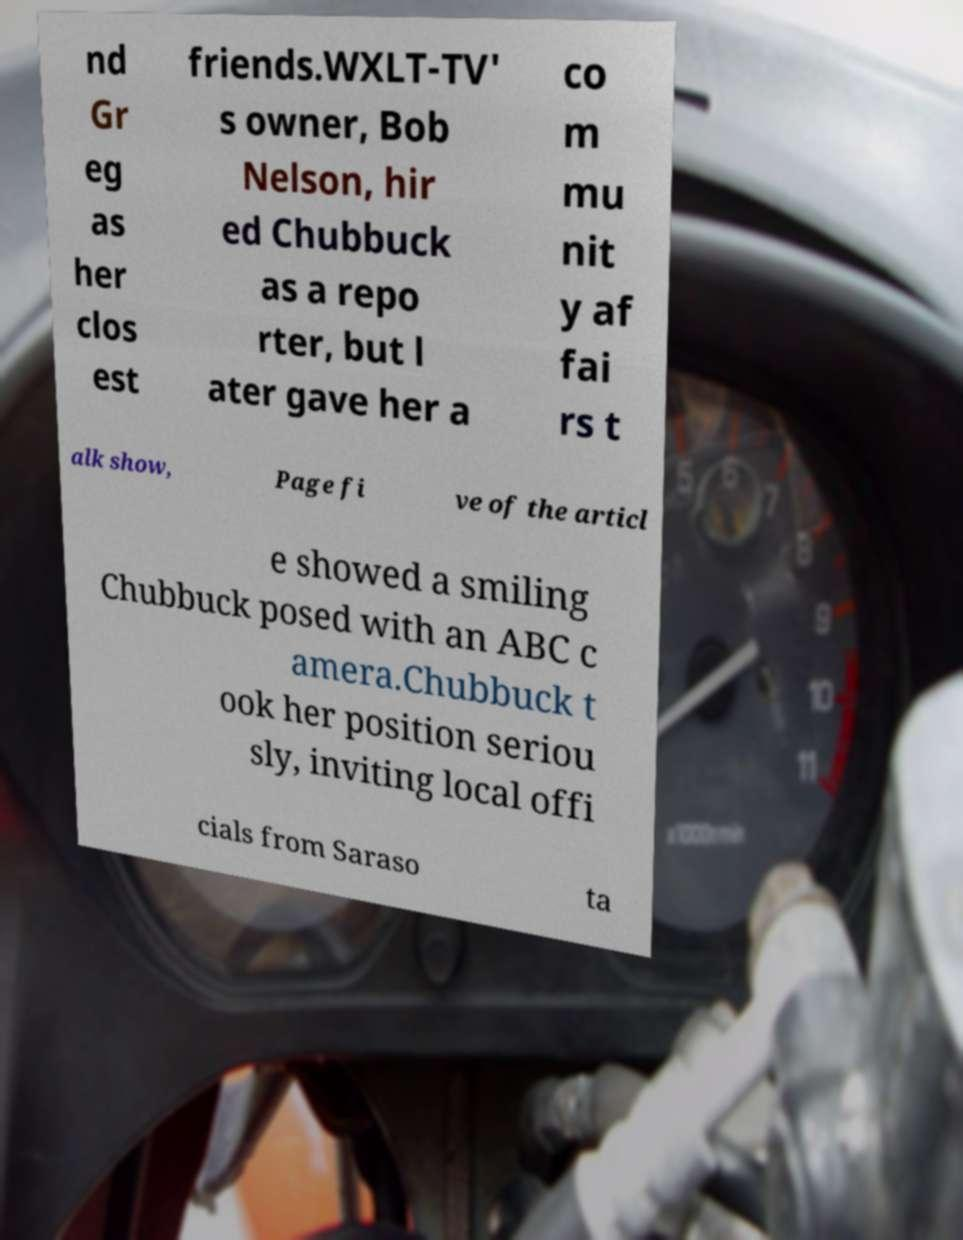Could you extract and type out the text from this image? nd Gr eg as her clos est friends.WXLT-TV' s owner, Bob Nelson, hir ed Chubbuck as a repo rter, but l ater gave her a co m mu nit y af fai rs t alk show, Page fi ve of the articl e showed a smiling Chubbuck posed with an ABC c amera.Chubbuck t ook her position seriou sly, inviting local offi cials from Saraso ta 